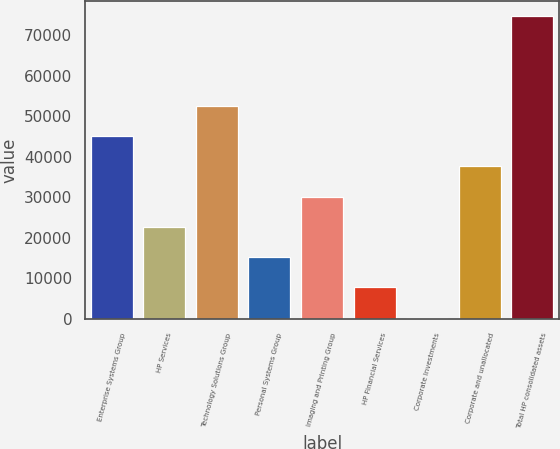Convert chart. <chart><loc_0><loc_0><loc_500><loc_500><bar_chart><fcel>Enterprise Systems Group<fcel>HP Services<fcel>Technology Solutions Group<fcel>Personal Systems Group<fcel>Imaging and Printing Group<fcel>HP Financial Services<fcel>Corporate Investments<fcel>Corporate and unallocated<fcel>Total HP consolidated assets<nl><fcel>45074<fcel>22727.6<fcel>52522.8<fcel>15278.8<fcel>30176.4<fcel>7830<fcel>228<fcel>37625.2<fcel>74716<nl></chart> 